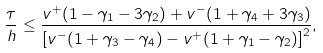Convert formula to latex. <formula><loc_0><loc_0><loc_500><loc_500>\frac { \tau } { h } \leq \frac { v ^ { + } ( 1 - \gamma _ { 1 } - 3 \gamma _ { 2 } ) + v ^ { - } ( 1 + \gamma _ { 4 } + 3 \gamma _ { 3 } ) } { { [ v ^ { - } ( 1 + \gamma _ { 3 } - \gamma _ { 4 } ) - v ^ { + } ( 1 + \gamma _ { 1 } - \gamma _ { 2 } ) ] } ^ { 2 } } ,</formula> 